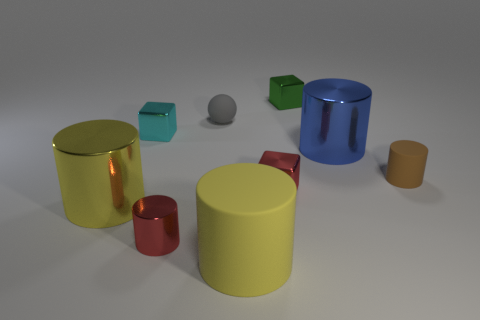There is a cube in front of the big metal thing behind the small brown thing; how big is it? The cube in the image appears to be relatively small in comparison to the other objects. Specifically, it looks to be smaller than the cylindrical objects and the sphere, which suggests it's a small object within this context. 